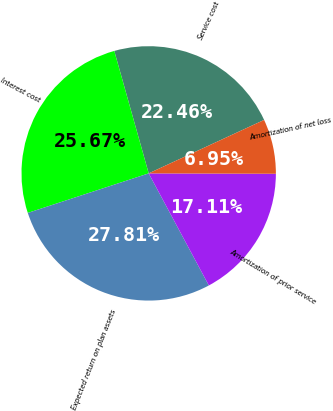Convert chart. <chart><loc_0><loc_0><loc_500><loc_500><pie_chart><fcel>Service cost<fcel>Interest cost<fcel>Expected return on plan assets<fcel>Amortization of prior service<fcel>Amortization of net loss<nl><fcel>22.46%<fcel>25.67%<fcel>27.81%<fcel>17.11%<fcel>6.95%<nl></chart> 